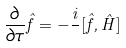Convert formula to latex. <formula><loc_0><loc_0><loc_500><loc_500>\frac { \partial } { \partial \tau } \hat { f } = - \frac { i } { } [ \hat { f } , \hat { H } ]</formula> 